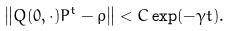<formula> <loc_0><loc_0><loc_500><loc_500>\left \| Q ( 0 , \cdot ) P ^ { t } - \rho \right \| < C \exp ( - \gamma t ) .</formula> 